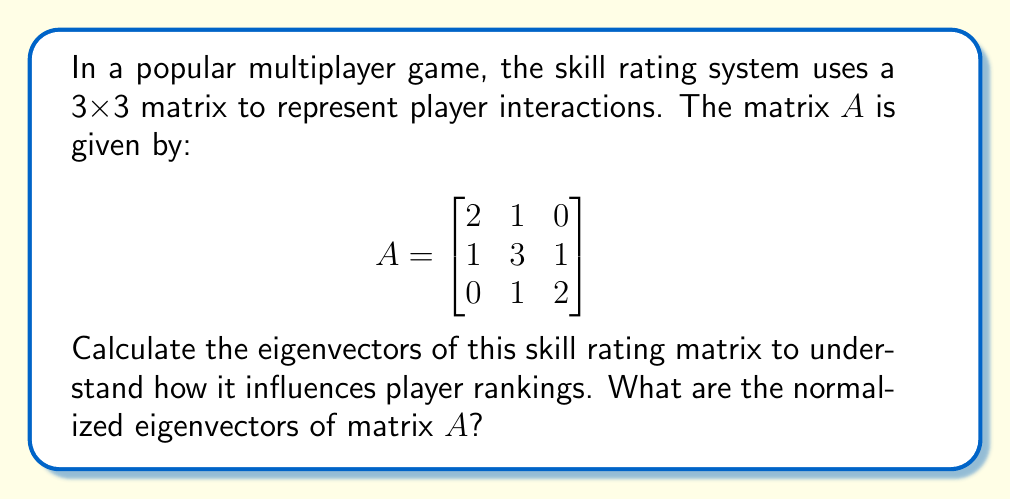Give your solution to this math problem. To find the eigenvectors of matrix $A$, we'll follow these steps:

1) First, we need to find the eigenvalues by solving the characteristic equation:
   $det(A - \lambda I) = 0$

2) Expanding the determinant:
   $\begin{vmatrix}
   2-\lambda & 1 & 0 \\
   1 & 3-\lambda & 1 \\
   0 & 1 & 2-\lambda
   \end{vmatrix} = 0$

3) This gives us the characteristic polynomial:
   $(2-\lambda)[(3-\lambda)(2-\lambda)-1] - 1(1)(2-\lambda) = 0$
   $(2-\lambda)[(6-5\lambda+\lambda^2)-1] - 1(2-\lambda) = 0$
   $(2-\lambda)(5-5\lambda+\lambda^2) - (2-\lambda) = 0$
   $\lambda^3 - 7\lambda^2 + 16\lambda - 12 = 0$

4) Factoring this polynomial:
   $(\lambda - 1)(\lambda - 3)(\lambda - 3) = 0$

5) The eigenvalues are $\lambda_1 = 1$, $\lambda_2 = \lambda_3 = 3$

6) Now, for each eigenvalue, we solve $(A - \lambda I)v = 0$ to find the eigenvectors:

   For $\lambda_1 = 1$:
   $$\begin{bmatrix}
   1 & 1 & 0 \\
   1 & 2 & 1 \\
   0 & 1 & 1
   \end{bmatrix} \begin{bmatrix} v_1 \\ v_2 \\ v_3 \end{bmatrix} = \begin{bmatrix} 0 \\ 0 \\ 0 \end{bmatrix}$$

   Solving this gives us $v_1 = -1$, $v_2 = 1$, $v_3 = -1$

   For $\lambda_2 = \lambda_3 = 3$:
   $$\begin{bmatrix}
   -1 & 1 & 0 \\
   1 & 0 & 1 \\
   0 & 1 & -1
   \end{bmatrix} \begin{bmatrix} v_1 \\ v_2 \\ v_3 \end{bmatrix} = \begin{bmatrix} 0 \\ 0 \\ 0 \end{bmatrix}$$

   Solving this gives us two linearly independent vectors:
   $v_2 = (1, 1, 1)$ and $v_3 = (1, 0, -1)$

7) Finally, we normalize these eigenvectors:

   $v_1 = \frac{1}{\sqrt{3}}(-1, 1, -1)$
   $v_2 = \frac{1}{\sqrt{3}}(1, 1, 1)$
   $v_3 = \frac{1}{\sqrt{2}}(1, 0, -1)$
Answer: $v_1 = \frac{1}{\sqrt{3}}(-1, 1, -1)$, $v_2 = \frac{1}{\sqrt{3}}(1, 1, 1)$, $v_3 = \frac{1}{\sqrt{2}}(1, 0, -1)$ 